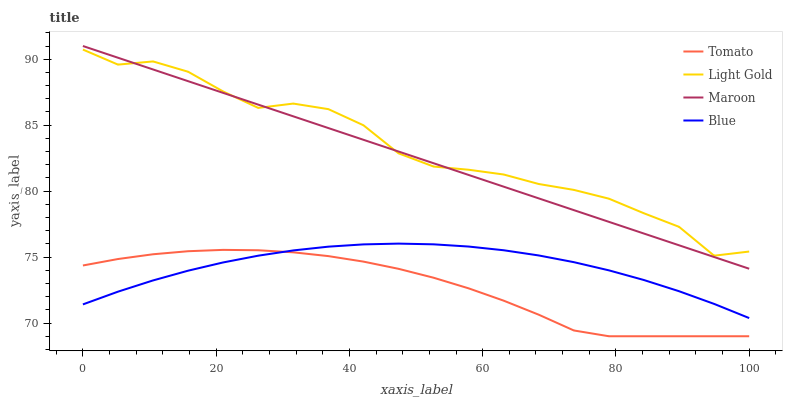Does Blue have the minimum area under the curve?
Answer yes or no. No. Does Blue have the maximum area under the curve?
Answer yes or no. No. Is Blue the smoothest?
Answer yes or no. No. Is Blue the roughest?
Answer yes or no. No. Does Blue have the lowest value?
Answer yes or no. No. Does Blue have the highest value?
Answer yes or no. No. Is Tomato less than Light Gold?
Answer yes or no. Yes. Is Maroon greater than Tomato?
Answer yes or no. Yes. Does Tomato intersect Light Gold?
Answer yes or no. No. 